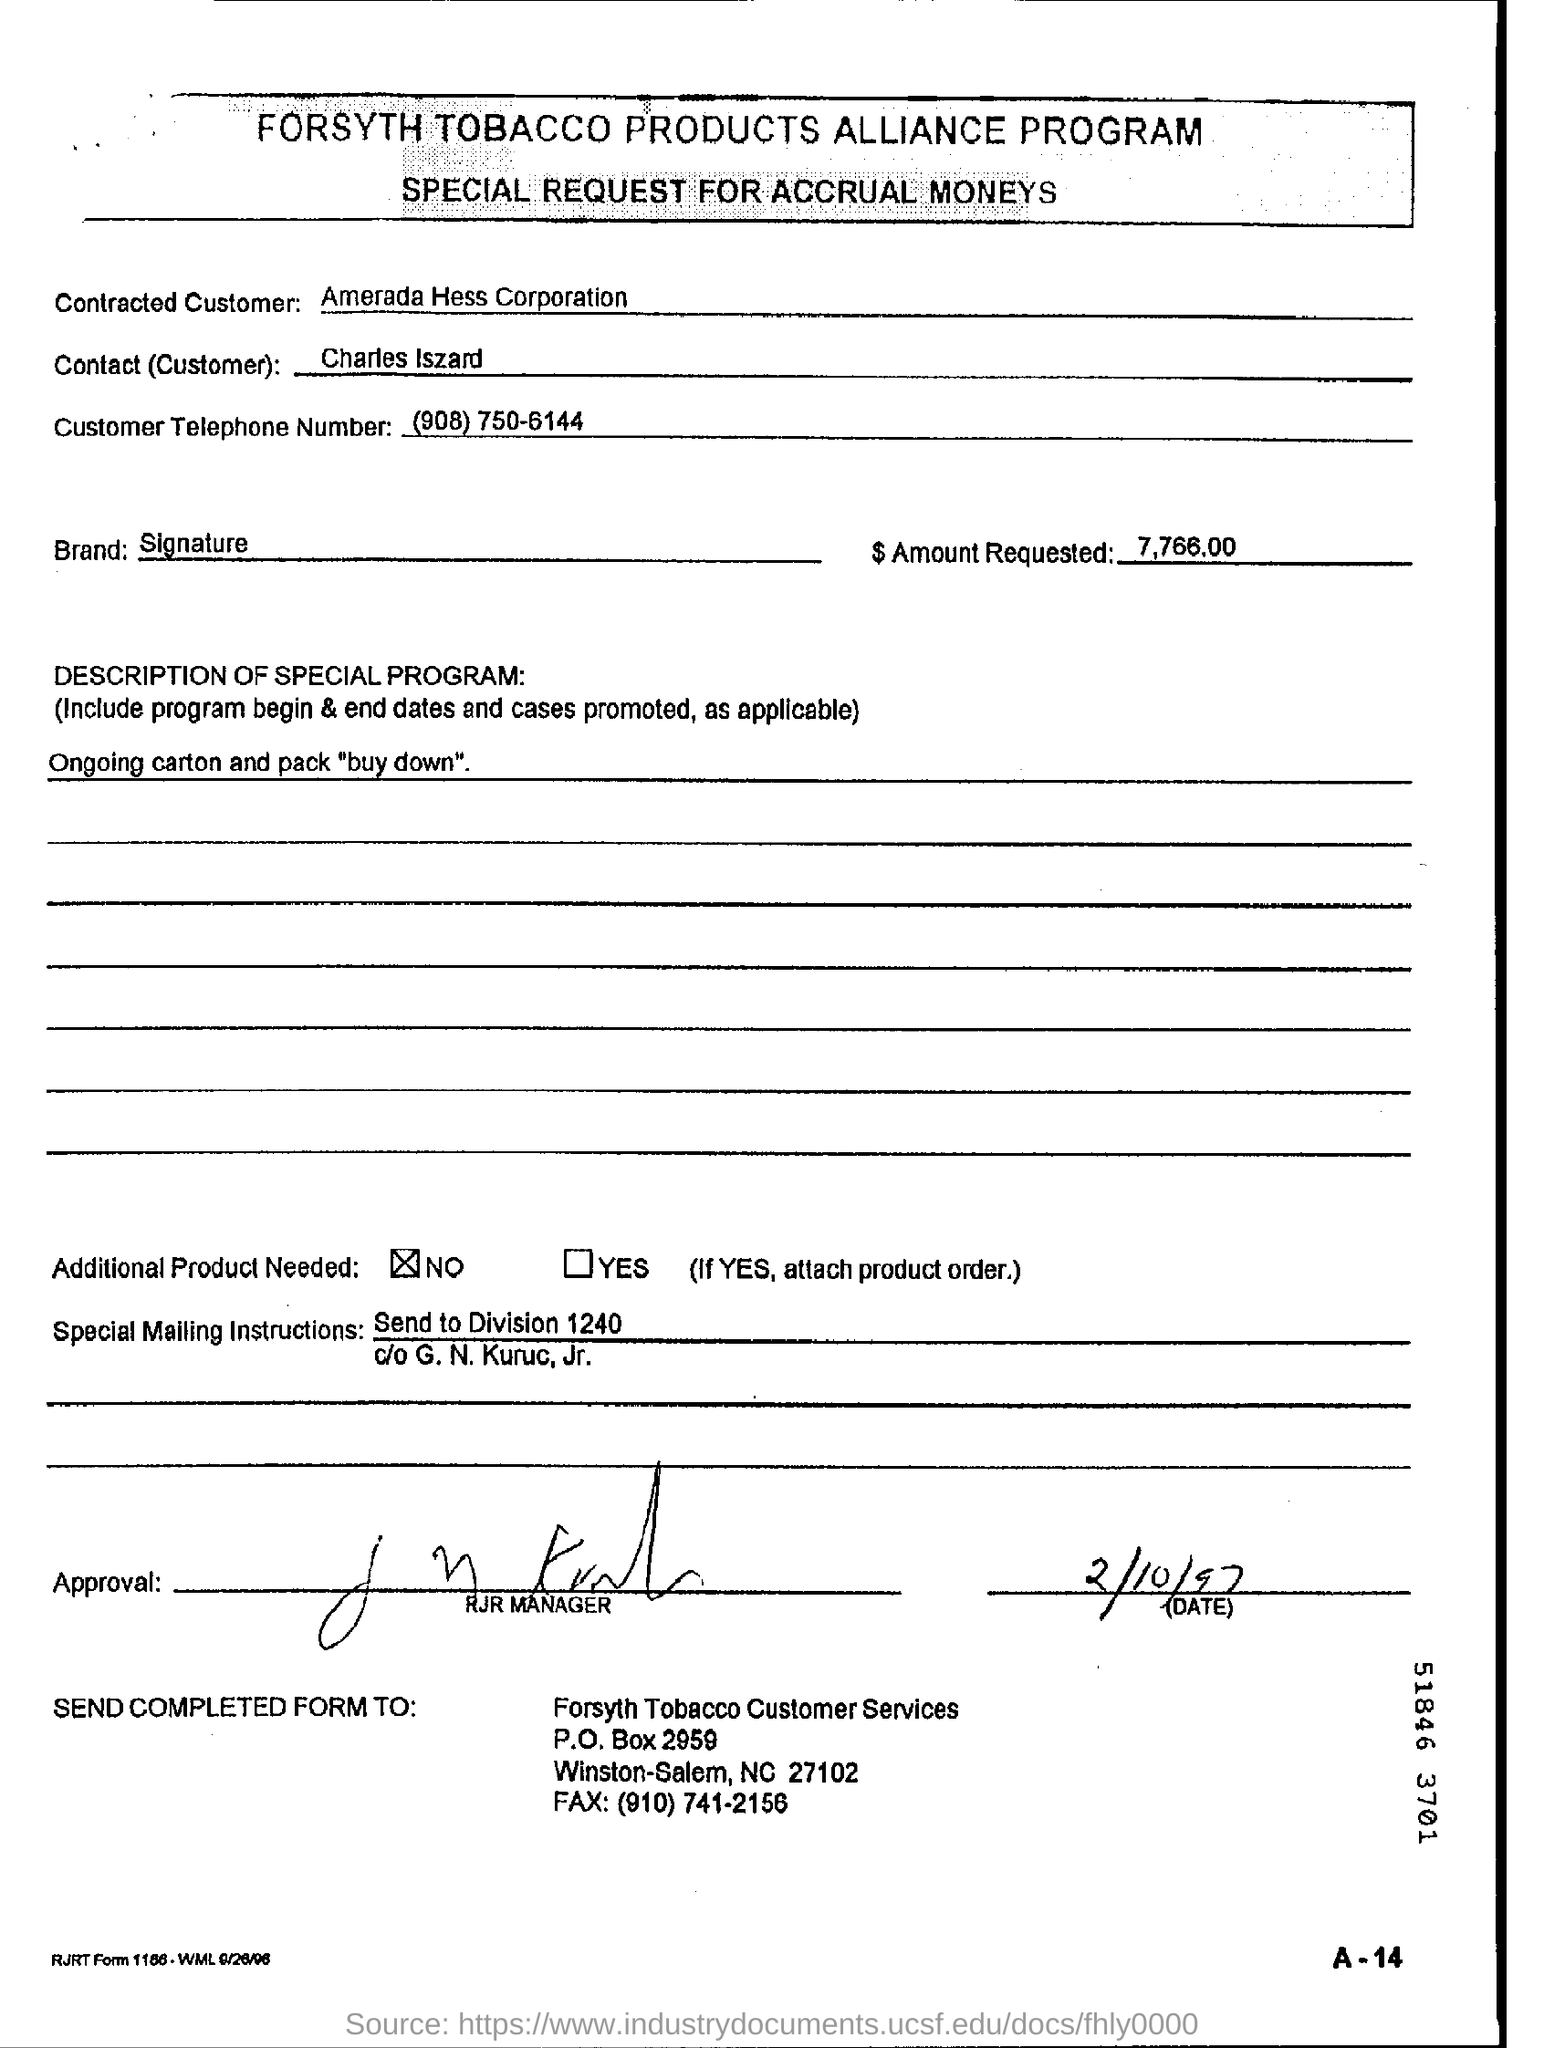Who is the Contracted Customer?
Give a very brief answer. Amerada hess corporation. What is the Contact(Customer)?
Your answer should be very brief. Charles iszard. What is the Customer Telephone Number?
Provide a succinct answer. (908) 750-6144. What is the $ Amount Requested?
Provide a short and direct response. 7,766.00. 